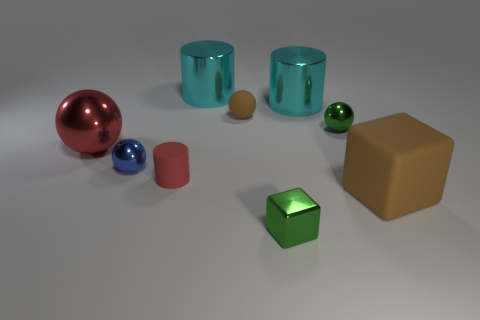Subtract all green spheres. How many spheres are left? 3 Subtract all cubes. How many objects are left? 7 Subtract 3 cylinders. How many cylinders are left? 0 Subtract all red cylinders. How many cylinders are left? 2 Add 5 tiny green metal cubes. How many tiny green metal cubes exist? 6 Subtract 0 blue cylinders. How many objects are left? 9 Subtract all brown cylinders. Subtract all yellow cubes. How many cylinders are left? 3 Subtract all brown blocks. How many gray cylinders are left? 0 Subtract all gray cubes. Subtract all large cyan things. How many objects are left? 7 Add 2 cyan things. How many cyan things are left? 4 